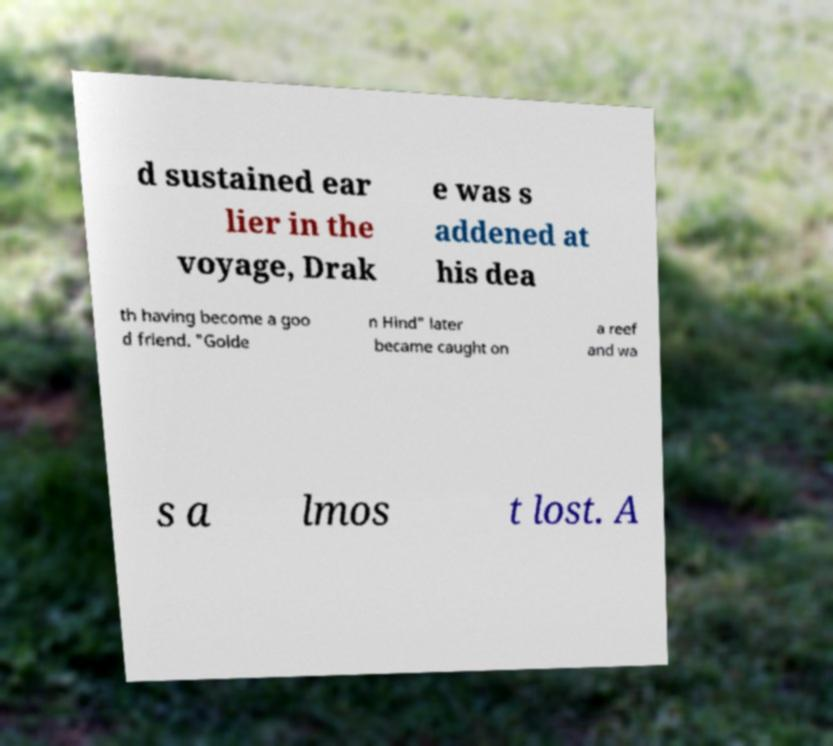Could you extract and type out the text from this image? d sustained ear lier in the voyage, Drak e was s addened at his dea th having become a goo d friend. "Golde n Hind" later became caught on a reef and wa s a lmos t lost. A 